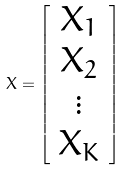<formula> <loc_0><loc_0><loc_500><loc_500>X = \left [ \begin{array} { c c } X _ { 1 } \\ X _ { 2 } \\ \vdots \\ X _ { K } \end{array} \right ]</formula> 